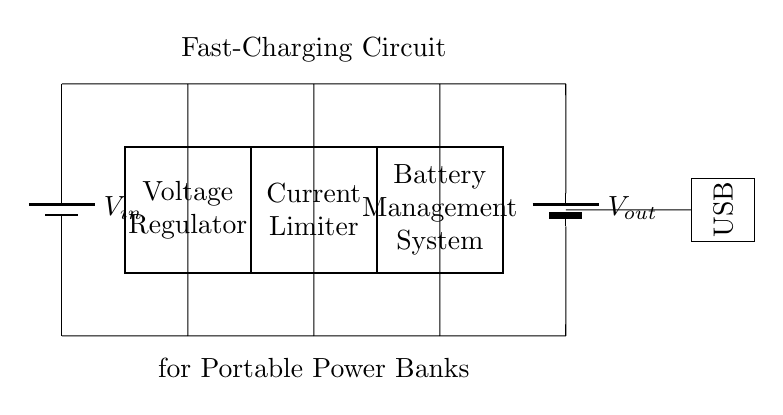What is the power source in this circuit? The power source in the circuit is represented by the battery labeled as V in, indicating it provides the input voltage necessary for the circuit operation.
Answer: V in What component regulates the voltage in the circuit? The component responsible for voltage regulation is the rectangular block labeled as "Voltage Regulator," which ensures the output voltage remains stable regardless of input variations.
Answer: Voltage Regulator What component limits the current in this fast-charging circuit? The current limiter, shown as a rectangular block labeled "Current Limiter" in the circuit diagram, is responsible for preventing excessive current from flowing to avoid damage to the connected components.
Answer: Current Limiter How many main functional components are present in the circuit? The circuit diagram contains four main functional components: the voltage regulator, current limiter, battery management system, and Li-ion battery.
Answer: Four What type of battery is used in this circuit? The circuit diagram includes a Li-ion battery, indicated by the symbol representing the battery and the associated label.
Answer: Li-ion battery Why is a battery management system important in this circuit? The battery management system oversees charging and discharging processes, ensuring safety, prolonging battery lifespan, and preventing overcharging. This is critical for maintaining optimal battery performance and reducing risks.
Answer: Safety and lifespan What is the output connection type for this fast-charging circuit? The output connection type is labeled as USB, illustrating that the circuit is designed to provide power through a Universal Serial Bus interface, which is commonly used for charging portable devices.
Answer: USB 